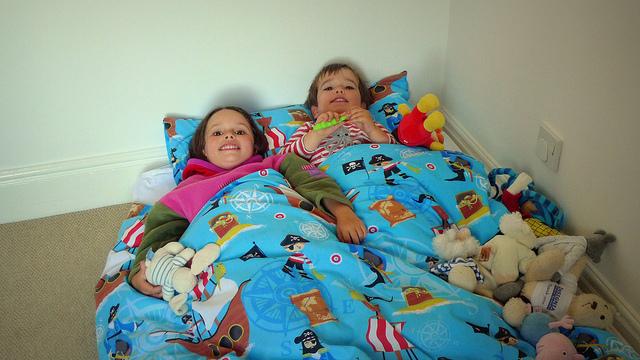Do the children in the scene look happy?
Be succinct. Yes. How many children are in the picture?
Keep it brief. 2. What color is the wall?
Concise answer only. White. 